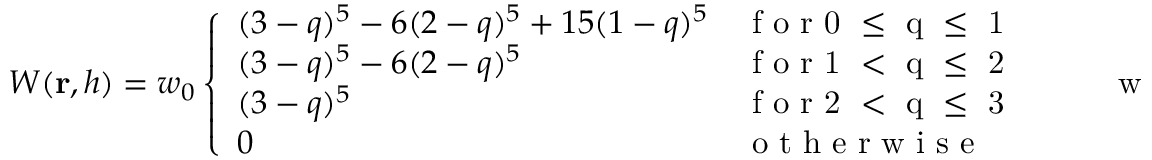<formula> <loc_0><loc_0><loc_500><loc_500>W ( r , h ) = w _ { 0 } \left \{ \begin{array} { l l } { ( 3 - q ) ^ { 5 } - 6 ( 2 - q ) ^ { 5 } + 1 5 ( 1 - q ) ^ { 5 } } & { f o r 0 \leq q \leq 1 } \\ { ( 3 - q ) ^ { 5 } - 6 ( 2 - q ) ^ { 5 } } & { f o r 1 < q \leq 2 } \\ { ( 3 - q ) ^ { 5 } } & { f o r 2 < q \leq 3 } \\ { 0 } & { o t h e r w i s e } \end{array} \quad w i t h \quad q = { \| } r { \| } / h ,</formula> 